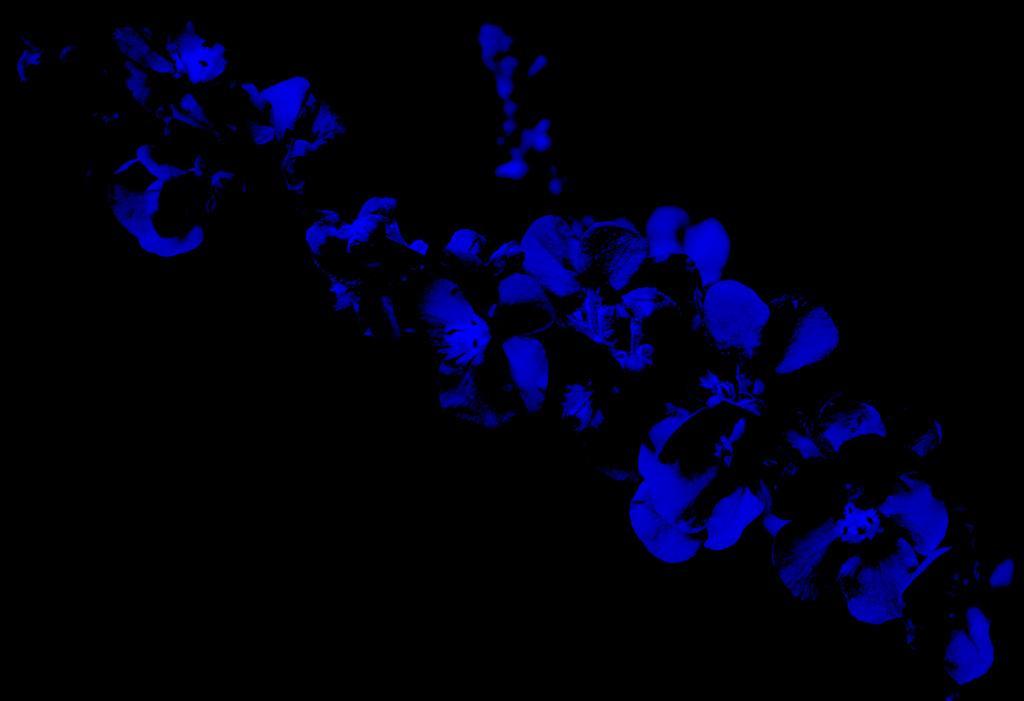Describe this image in one or two sentences. In this image we can see blue flowers. Background it is in black color. 